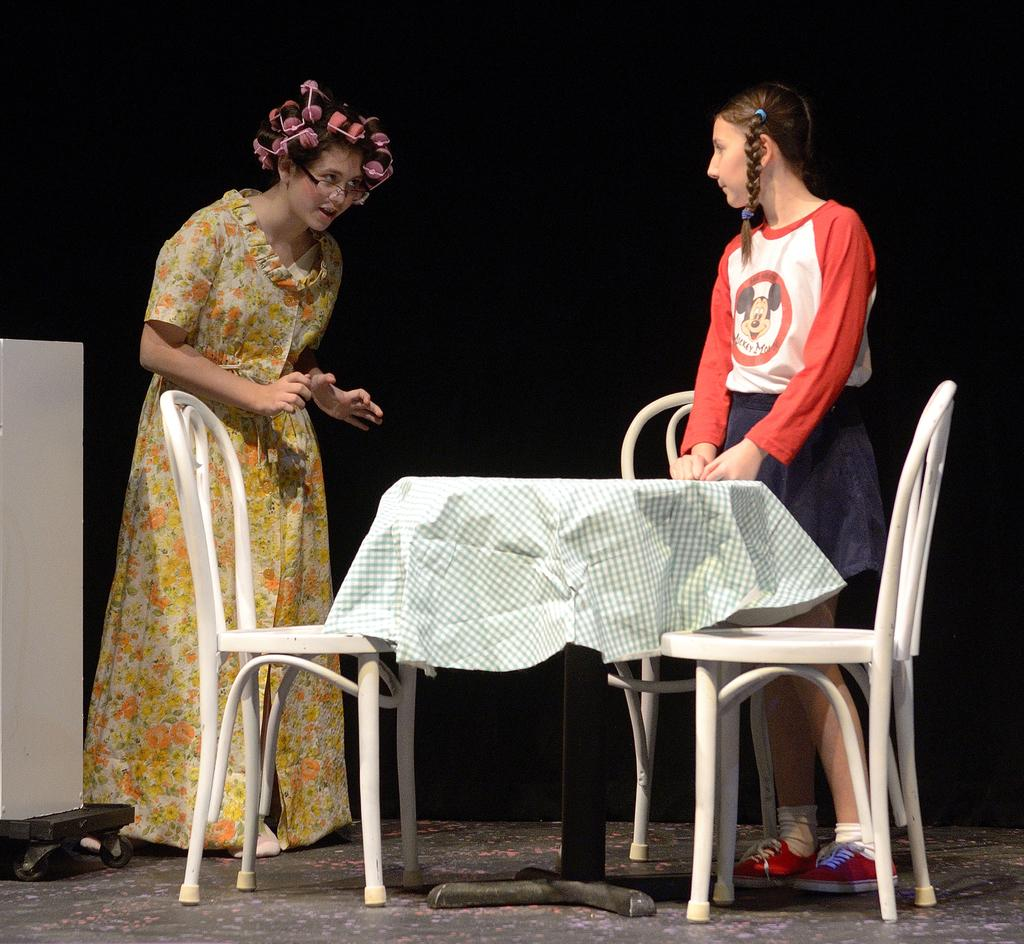How many people are in the image? There are two persons in the image. What are the two persons doing in the image? The two persons are standing around a table. How many chairs are visible in the image? There are three empty chairs in the image. Can you describe the cloth in the image? There is one cloth in the image. What direction is the blade pointing in the image? There is no blade present in the image. What type of land can be seen in the image? The image does not depict any land; it features two persons standing around a table with chairs and a cloth. 